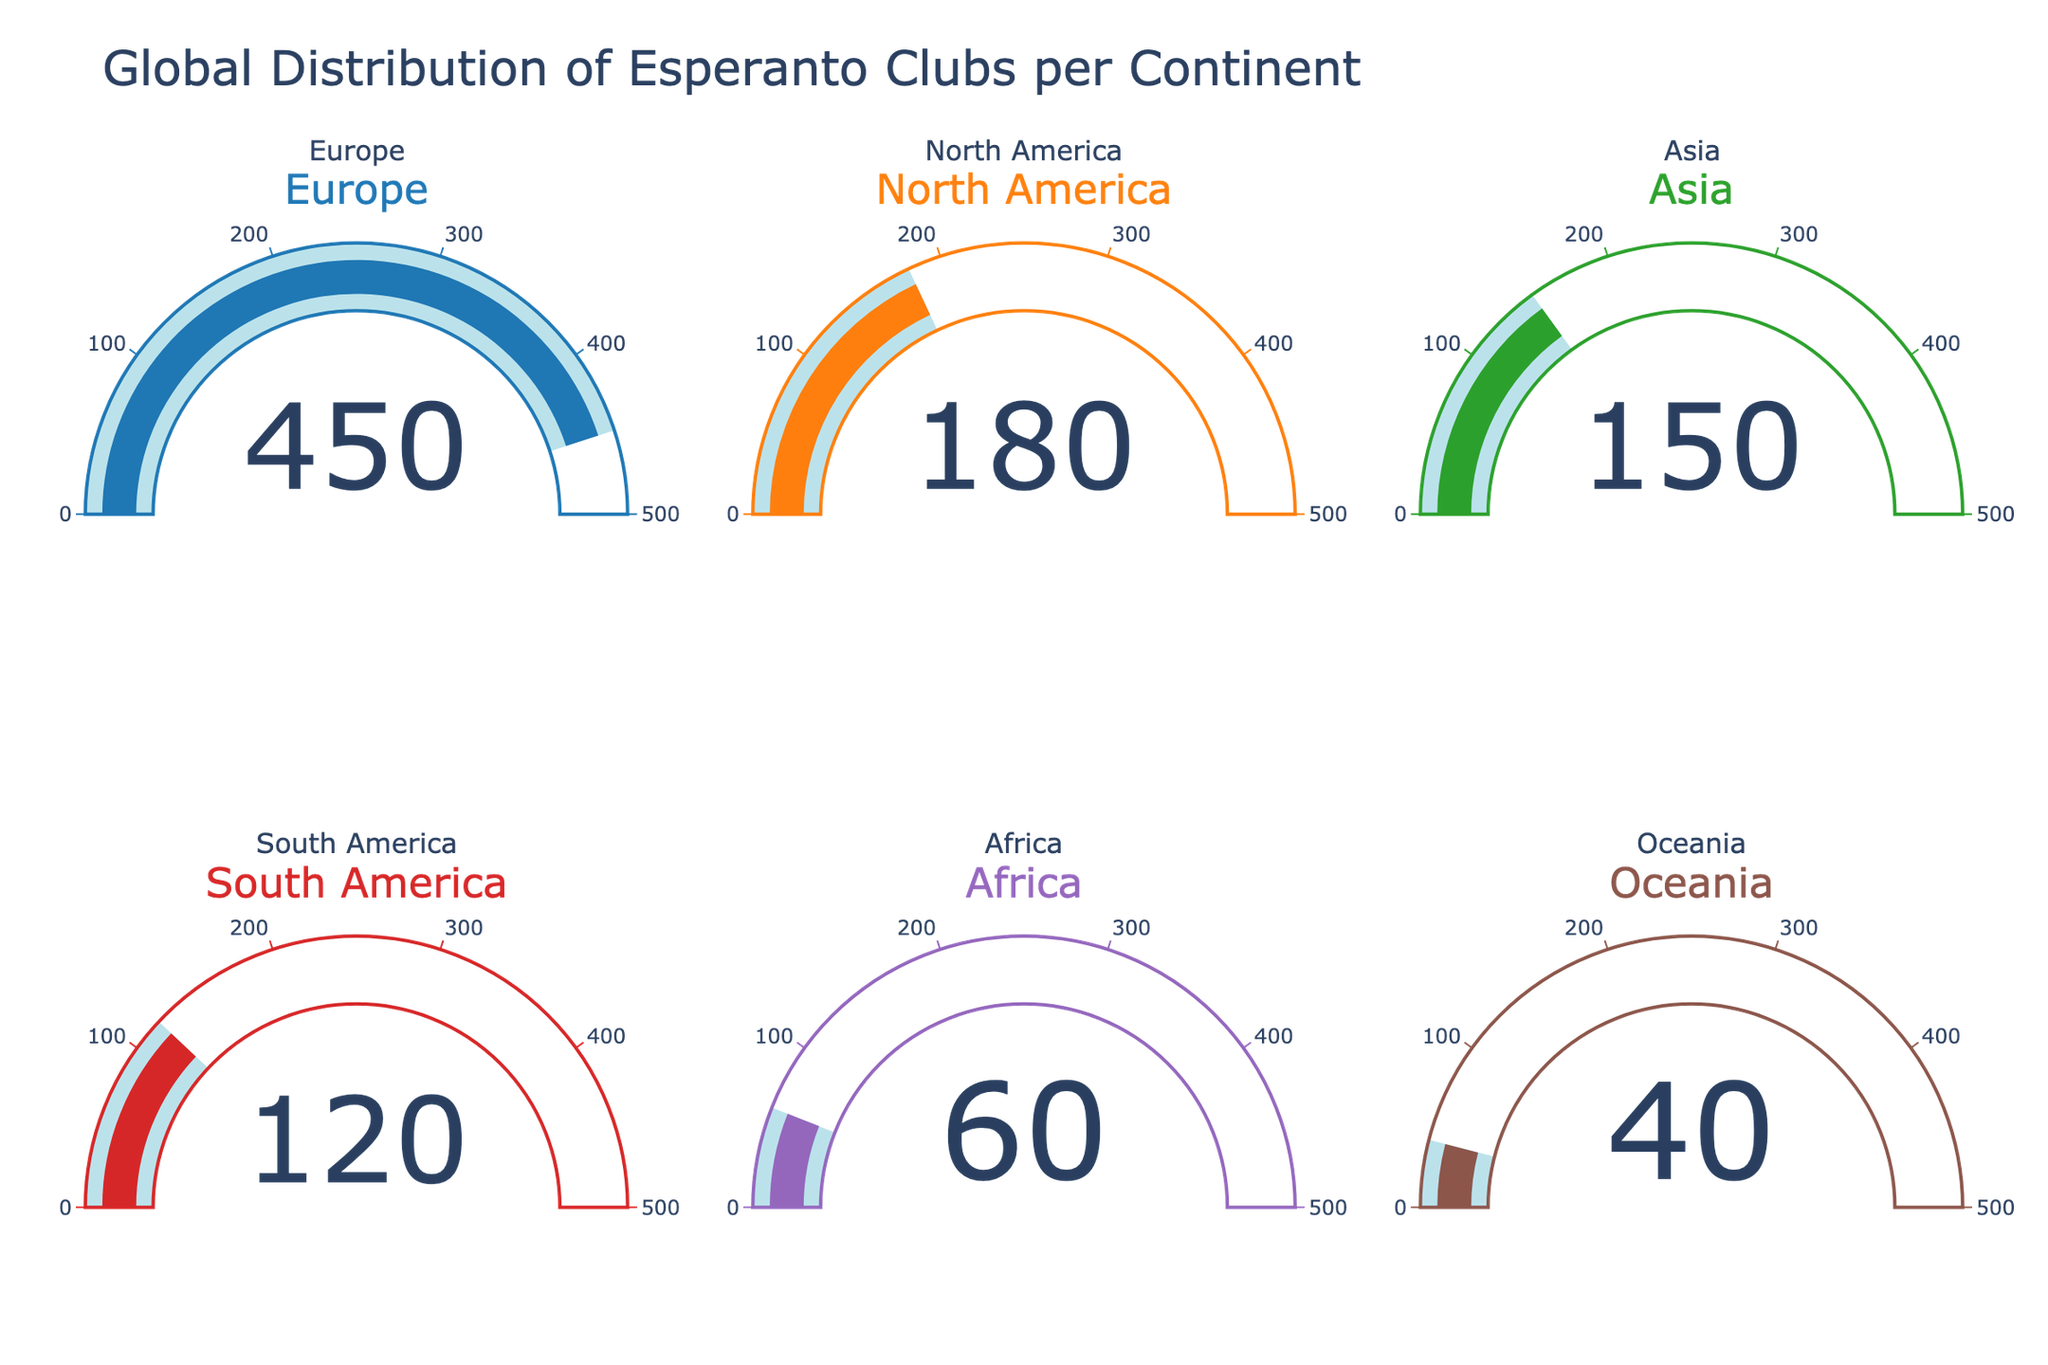What's the title of the figure? The title of the figure is displayed at the top of the plot.
Answer: Global Distribution of Esperanto Clubs per Continent How many Esperanto clubs are there in Europe? The number displayed on the gauge for Europe shows the number of clubs.
Answer: 450 Which continent has the fewest Esperanto clubs? To find the continent with the fewest clubs, compare the numbers on each gauge and identify the lowest one.
Answer: Oceania What is the total number of Esperanto clubs in North America and Asia combined? Add the values shown on the gauges for North America and Asia: 180 (North America) + 150 (Asia).
Answer: 330 How many more Esperanto clubs are there in Europe than in Africa? Subtract the number of clubs in Africa from the number of clubs in Europe: 450 (Europe) - 60 (Africa).
Answer: 390 Which continent has the second highest number of Esperanto clubs? First, identify the highest number (Europe with 450), then find the next highest value (North America with 180).
Answer: North America Are there more Esperanto clubs in South America or Oceania? Compare the values on the respective gauges: South America (120) vs. Oceania (40).
Answer: South America What is the average number of Esperanto clubs per continent? Add all the club numbers and divide by the number of continents: (450 + 180 + 150 + 120 + 60 + 40) / 6.
Answer: 166.67 Which continents have fewer than 100 Esperanto clubs? Identify the continents with club numbers below 100: Africa (60) and Oceania (40).
Answer: Africa, Oceania How many continents have more than 150 Esperanto clubs? Identify the number of continents with club counts over 150: Europe (450), North America (180).
Answer: 2 